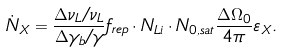Convert formula to latex. <formula><loc_0><loc_0><loc_500><loc_500>\dot { N } _ { X } = \frac { \Delta \nu _ { L } / \nu _ { L } } { \Delta \gamma _ { b } / \gamma } f _ { r e p } \cdot N _ { L i } \cdot N _ { 0 , s a t } \frac { \Delta \Omega _ { 0 } } { 4 \pi } \varepsilon _ { X } .</formula> 